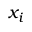Convert formula to latex. <formula><loc_0><loc_0><loc_500><loc_500>x _ { i }</formula> 